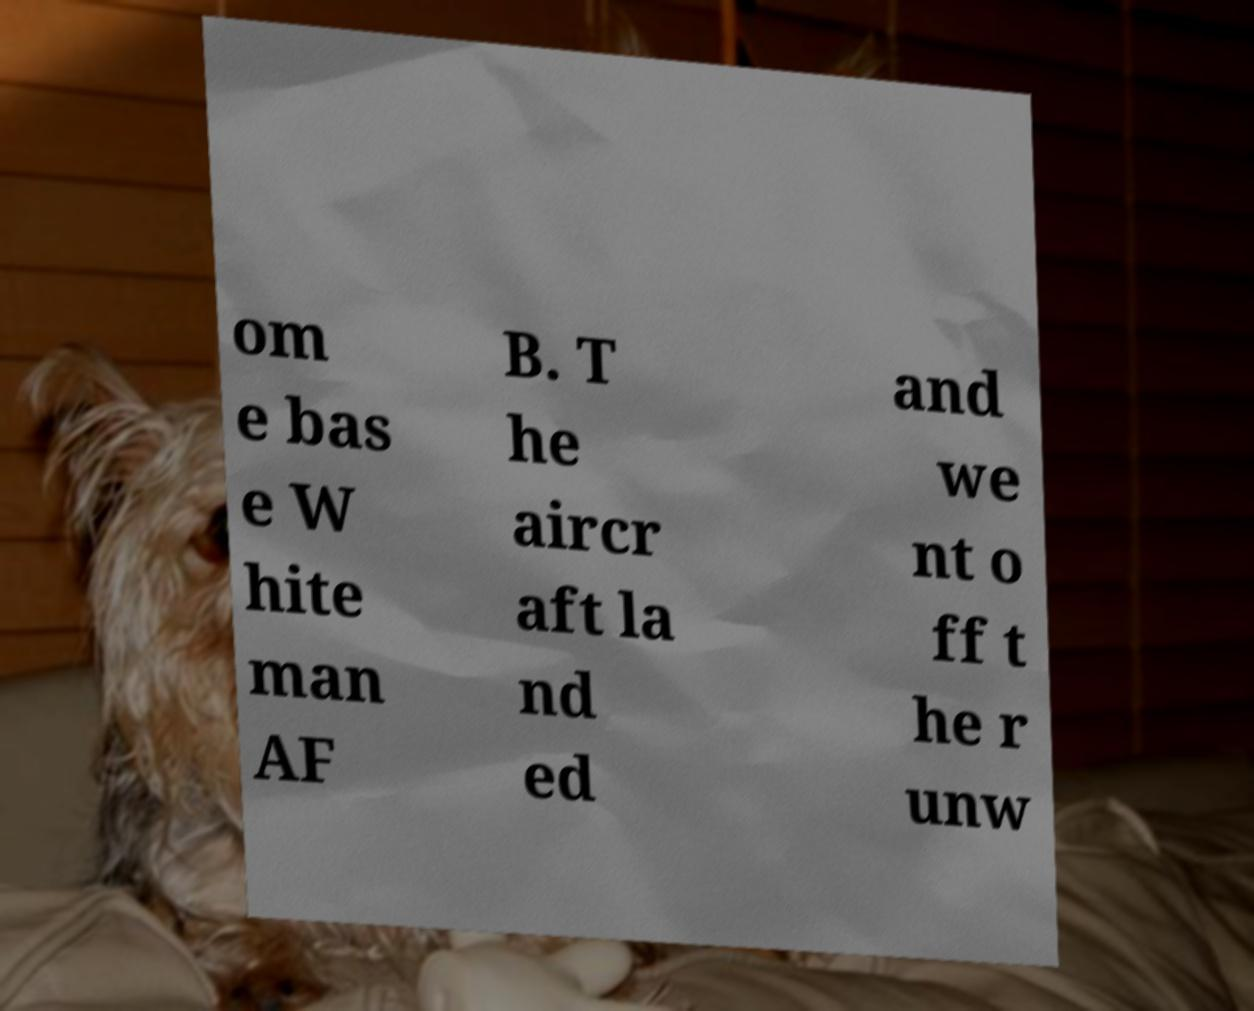There's text embedded in this image that I need extracted. Can you transcribe it verbatim? om e bas e W hite man AF B. T he aircr aft la nd ed and we nt o ff t he r unw 